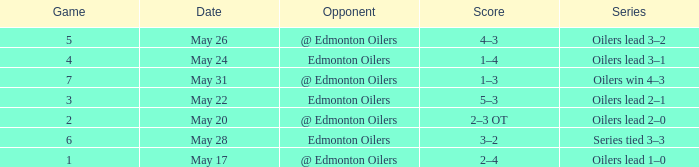Opponent of @ edmonton oilers, and a Game smaller than 7, and a Series of oilers lead 3–2 had what score? 4–3. 